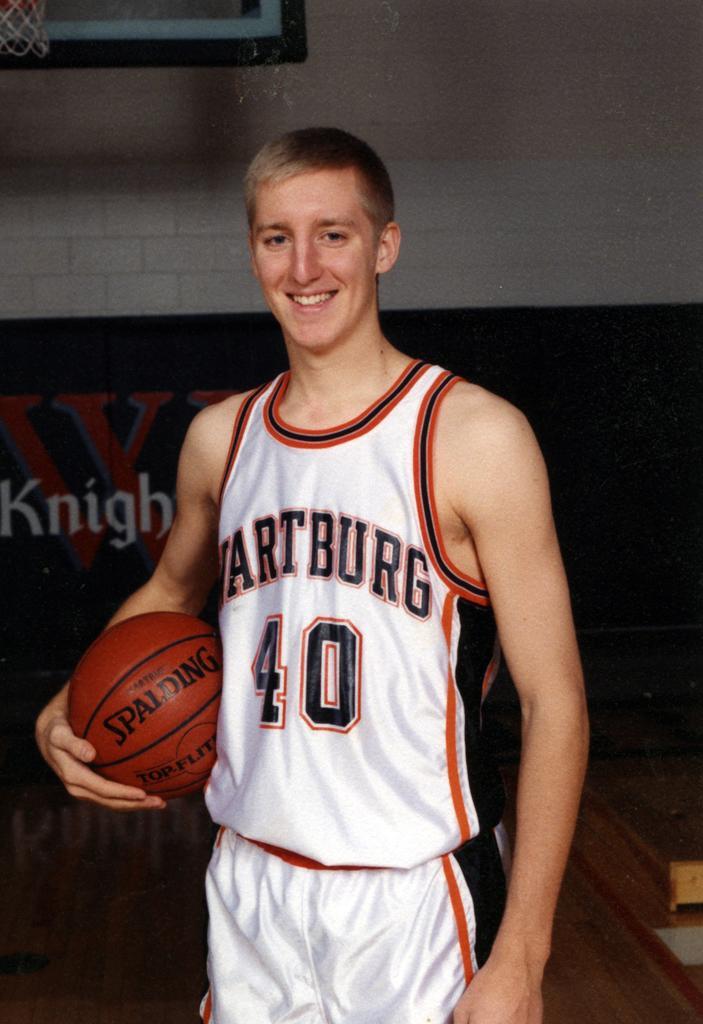Can you describe this image briefly? In the center of the picture there is a boy in white dress holding a basketball, he is smiling. On the top left there is basketball net. In the background there is a banner and wall. 